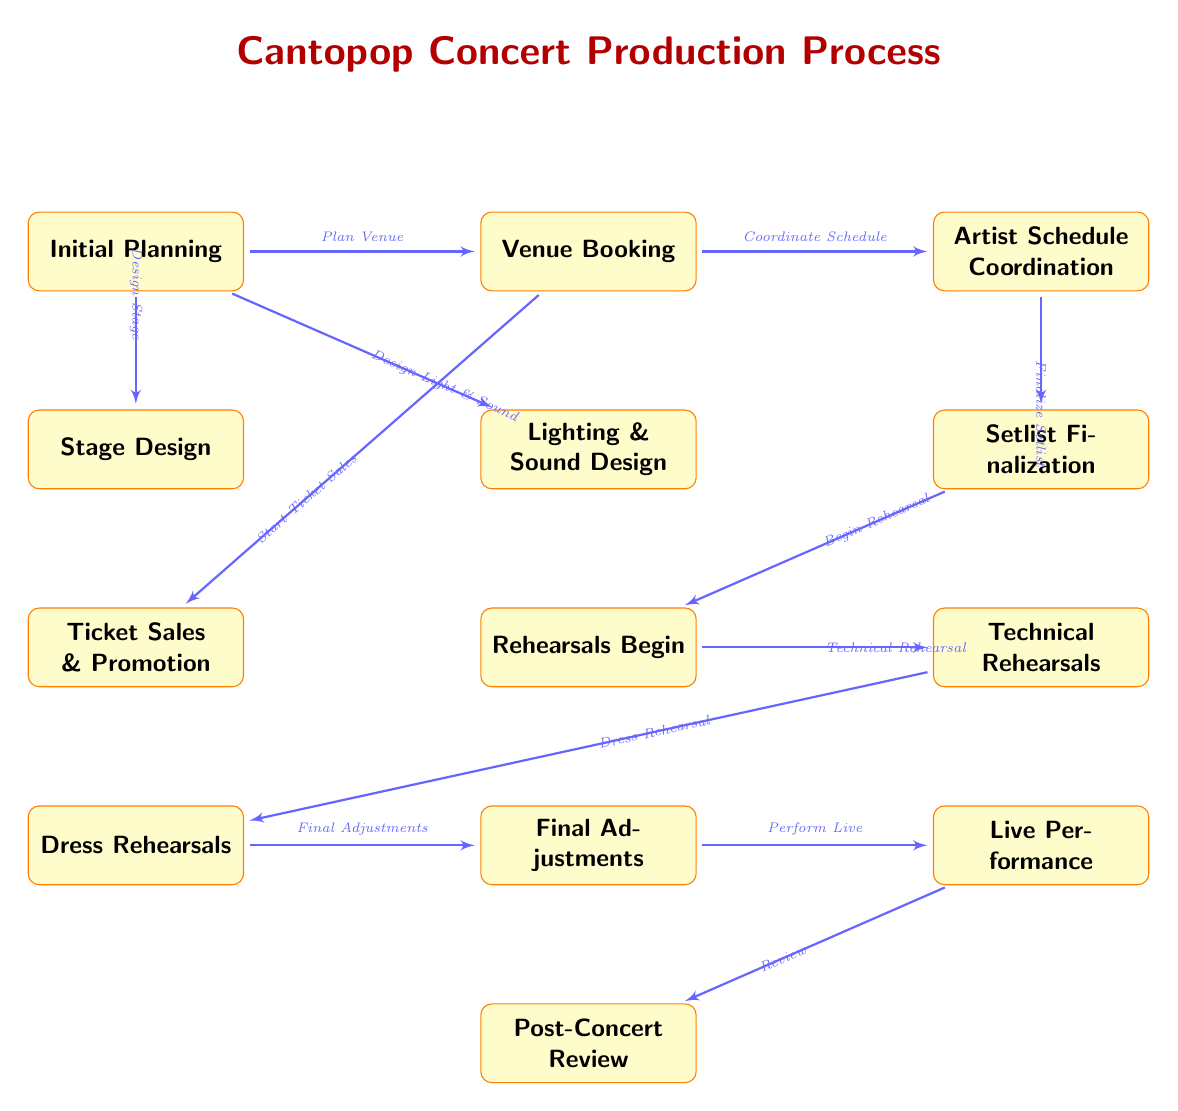What is the first stage in the Cantopop concert production process? The first stage, located at the top of the diagram, is labeled "Initial Planning."
Answer: Initial Planning How many main stages are there in the process? Counting the boxes in the diagram, there are a total of 13 stages that constitute the concert production process.
Answer: 13 Which stage is directly after "Stage Design"? "Lighting & Sound Design" is the stage that follows "Stage Design" as indicated by their vertical positioning in the diagram.
Answer: Lighting & Sound Design What is the last stage in the concert production process? The last stage can be found at the bottom of the diagram labeled "Post-Concert Review," which is the final step after the live performance.
Answer: Post-Concert Review What step follows "Final Adjustments"? The step that comes after "Final Adjustments" is "Perform Live," as indicated by the arrow connection in the diagram flowing downwards from the former to the latter.
Answer: Perform Live What action is taken before the technical rehearsals? The action that precedes "Technical Rehearsals" is "Rehearsals Begin," which directly connects to technical rehearsals in the flow of the overall concert preparation stages.
Answer: Rehearsals Begin What do you need to do before booking the venue? Before booking the venue, you need to "Plan Venue," which is the first step in the process and is connected to "Venue Booking."
Answer: Plan Venue How are "Ticket Sales & Promotion" and "Lighting & Sound Design" connected? "Ticket Sales & Promotion" is positioned below "Venue Booking" while "Lighting & Sound Design" is below "Venue Booking" as well; they are indirectly connected through their relationship to the venue stage.
Answer: Indirectly related through Venue Booking What is the relationship between "Dress Rehearsals" and "Technical Rehearsals"? "Dress Rehearsals" and "Technical Rehearsals" are sequential stages, with "Technical Rehearsals" coming before "Dress Rehearsals," forming a linear connection in the rehearsal phase of the diagram.
Answer: Sequential relationship 